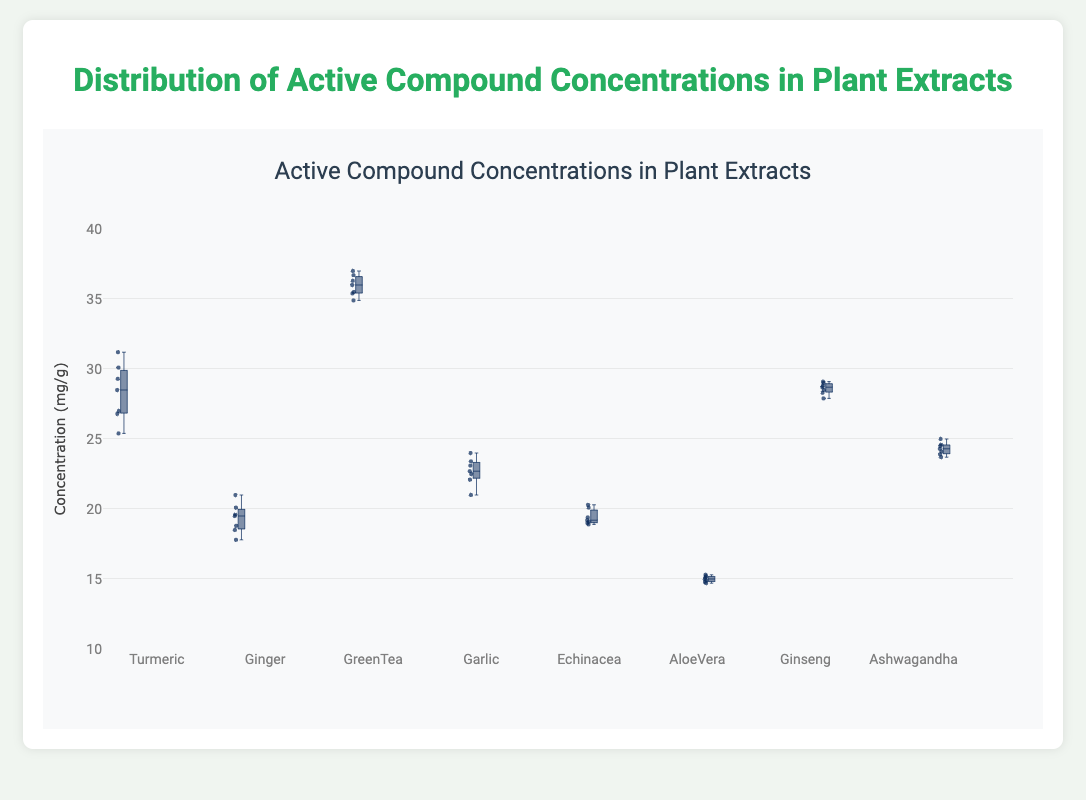What is the title of the figure? The title of the figure is typically displayed at the top. In this case, the title is "Distribution of Active Compound Concentrations in Plant Extracts". This is evident since it’s directly stated as such.
Answer: Distribution of Active Compound Concentrations in Plant Extracts Which plant extract has the highest spread in active compound concentrations? To determine this, observe the length of the boxes and whiskers in the plot. GreenTea has the largest spread as it has the longest box and whiskers.
Answer: GreenTea Which plant extract has the highest median concentration of active compounds? Look for the horizontal line inside each box, which marks the median. GreenTea has the highest median concentration compared to others.
Answer: GreenTea What is the range of active compound concentrations in AloeVera? The range can be determined by looking at the minimum and maximum values represented by the whiskers. AloeVera ranges approximately from 14.7 to 15.3 mg/g.
Answer: 14.7 to 15.3 mg/g Which plant extract has the lowest median concentration of active compounds? The median is marked by the line inside the box. AloeVera has the lowest median compared to other plants.
Answer: AloeVera What is the median concentration of active compounds in Ginseng? Identify the line inside the box for Ginseng, which indicates the median. The median for Ginseng is around 28.7 mg/g.
Answer: 28.7 mg/g How does the dispersion of active compound concentrations in Ashwagandha compare with Turmeric? The dispersion can be observed via the extent of the box and whiskers. Turmeric shows a wider dispersion compared to Ashwagandha, indicating more variability in its concentration levels.
Answer: Turmeric has greater dispersion Which plant extracts have median concentrations over 25 mg/g? Check the horizontal lines inside the boxes (medians) and identify those above the 25 mg/g mark. Turmeric, GreenTea, and Ginseng have medians over 25 mg/g.
Answer: Turmeric, GreenTea, Ginseng Are there any plant extracts with all their data points closely clustered? If so, which ones? A close cluster implies minimal spread of data points around the box. AloeVera has its data points closely clustered.
Answer: AloeVera What is the interquartile range (IQR) of the active compound concentrations in Garlic? The IQR is the difference between the third quartile (Q3) and the first quartile (Q1). For Garlic, visually extrapolate the values at the ends of the box. The IQR for Garlic is approximately 2 mg/g (from around 21 to 23).
Answer: 2 mg/g 